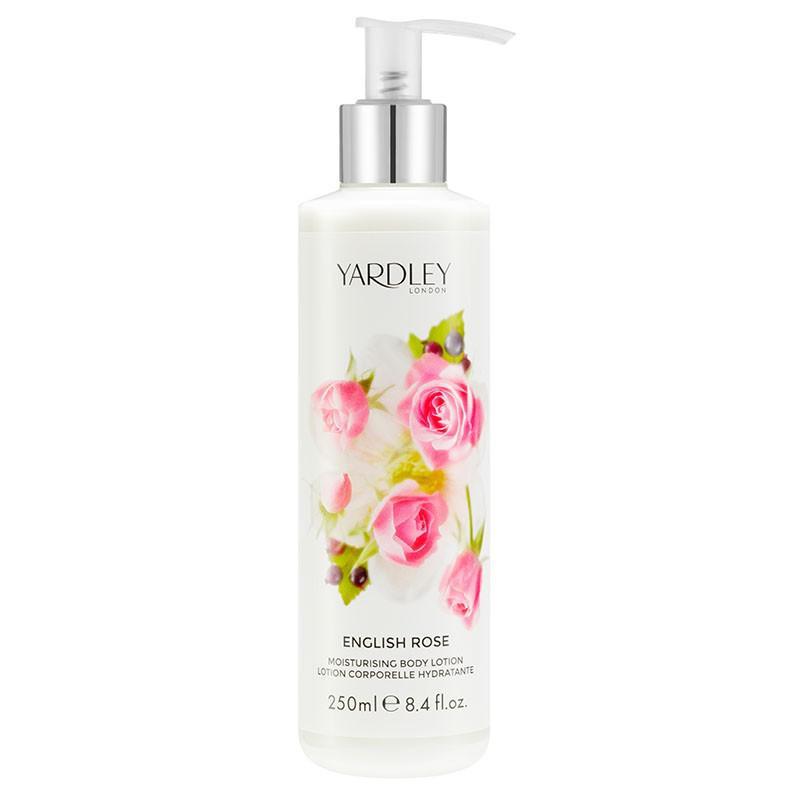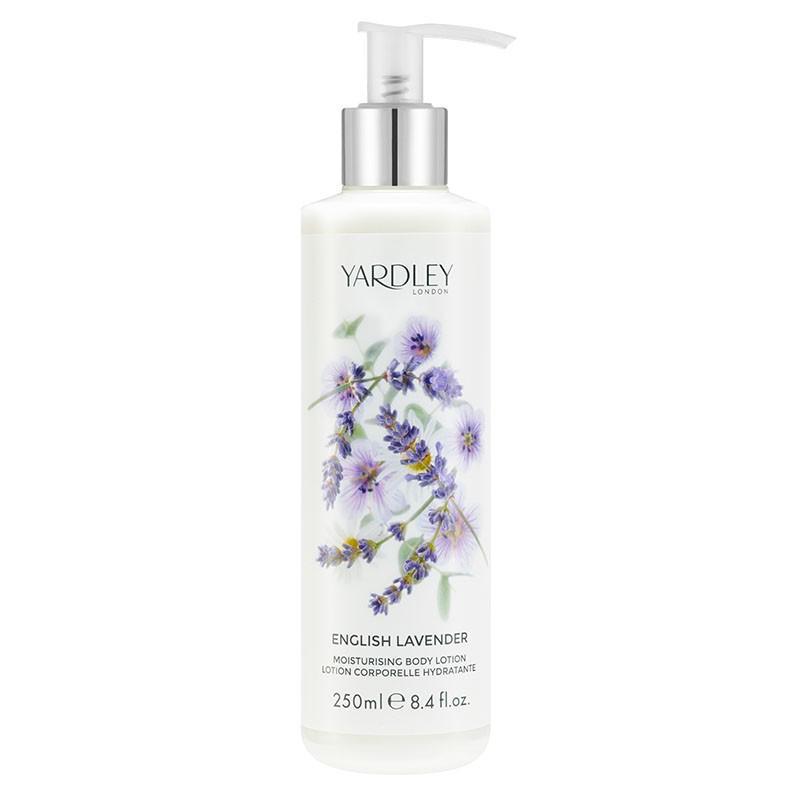The first image is the image on the left, the second image is the image on the right. Considering the images on both sides, is "The right image shows a single product, which is decorated with lavender flowers, and left and right images show products in the same shape and applicator formats." valid? Answer yes or no. Yes. The first image is the image on the left, the second image is the image on the right. Considering the images on both sides, is "Two containers of body wash have their cap on the bottom." valid? Answer yes or no. No. 